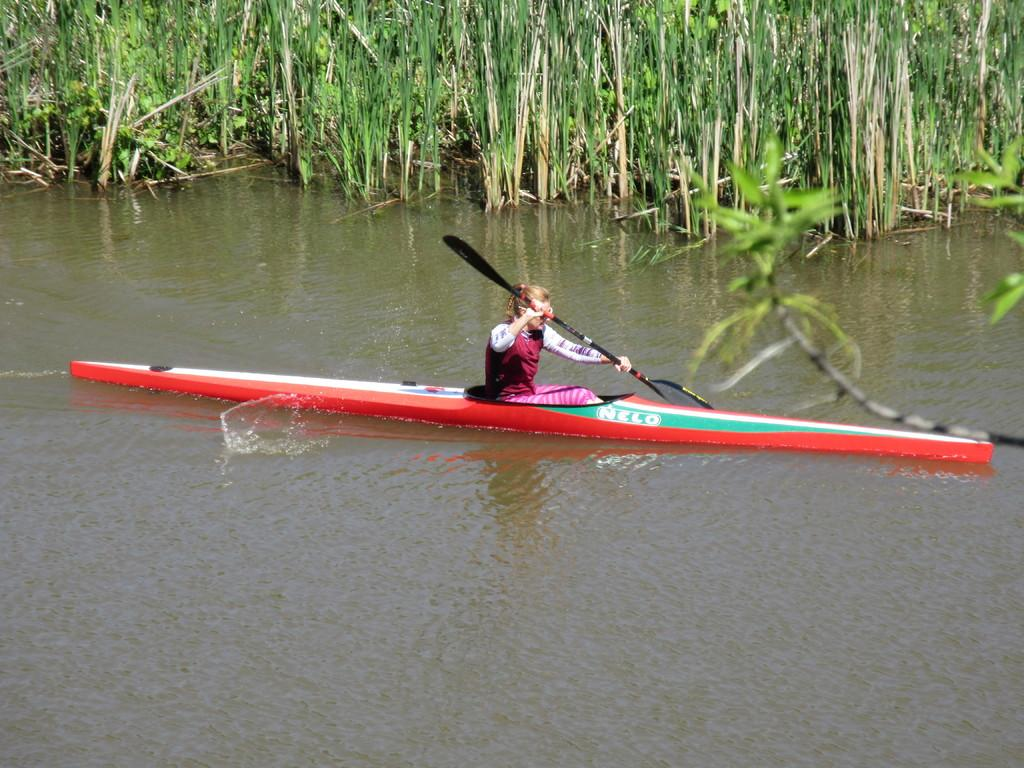Who is the main subject in the image? There is a girl in the image. What is the girl doing in the image? The girl is on a boat. Where is the boat located? The boat is sailing on a river. What can be seen in the background of the image? There are plants in the background of the image. What is on the right side of the image? There is a tree on the right side of the image. What type of alarm is ringing on the boat in the image? There is no alarm present in the image; it is a girl on a boat sailing on a river. 